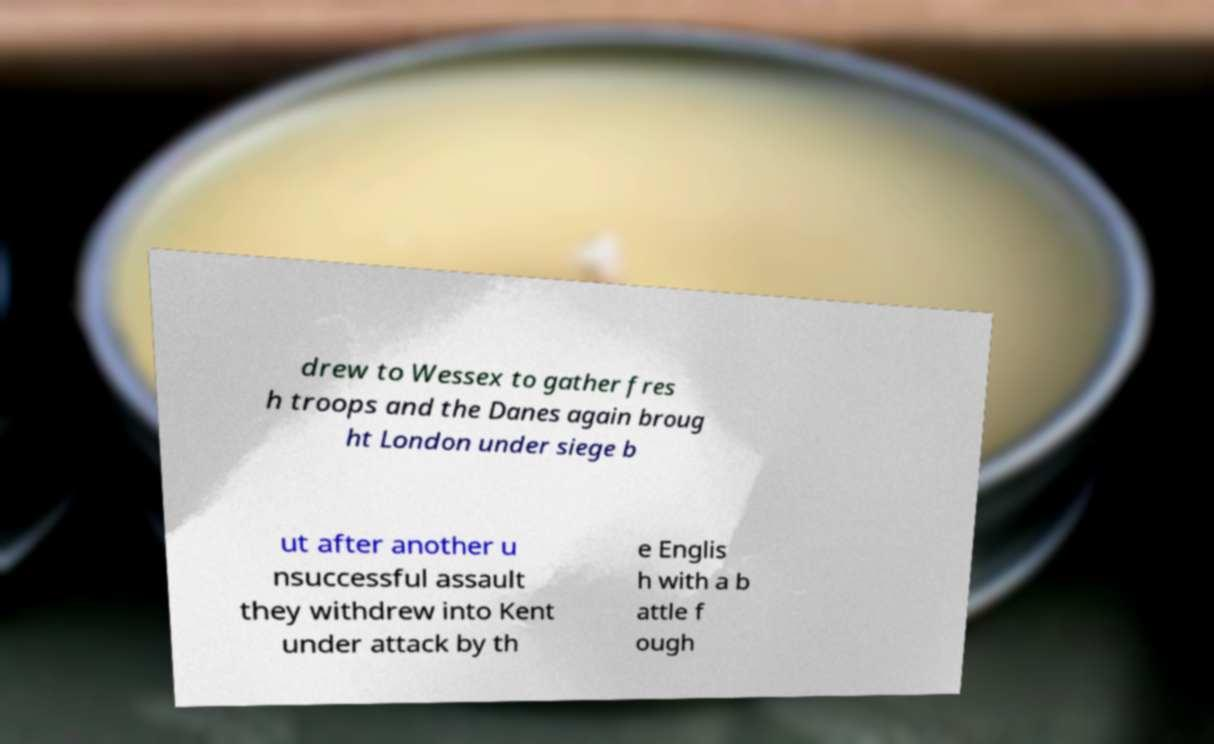Could you extract and type out the text from this image? drew to Wessex to gather fres h troops and the Danes again broug ht London under siege b ut after another u nsuccessful assault they withdrew into Kent under attack by th e Englis h with a b attle f ough 